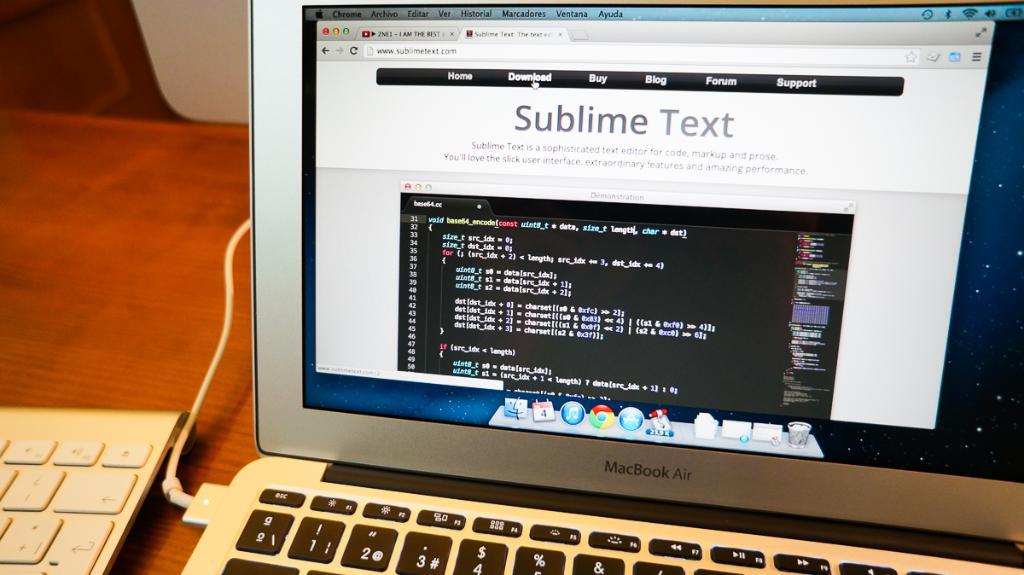What kind of computer is this?
Offer a terse response. Macbook air. What brand laptop is in the picture?
Offer a terse response. Macbook air. 